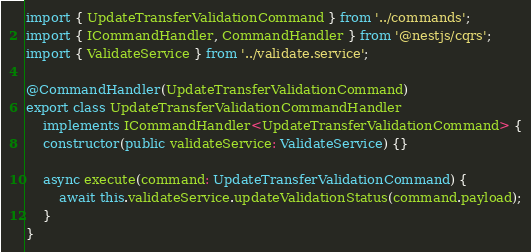<code> <loc_0><loc_0><loc_500><loc_500><_TypeScript_>import { UpdateTransferValidationCommand } from '../commands';
import { ICommandHandler, CommandHandler } from '@nestjs/cqrs';
import { ValidateService } from '../validate.service';

@CommandHandler(UpdateTransferValidationCommand)
export class UpdateTransferValidationCommandHandler
    implements ICommandHandler<UpdateTransferValidationCommand> {
    constructor(public validateService: ValidateService) {}

    async execute(command: UpdateTransferValidationCommand) {
        await this.validateService.updateValidationStatus(command.payload);
    }
}
</code> 